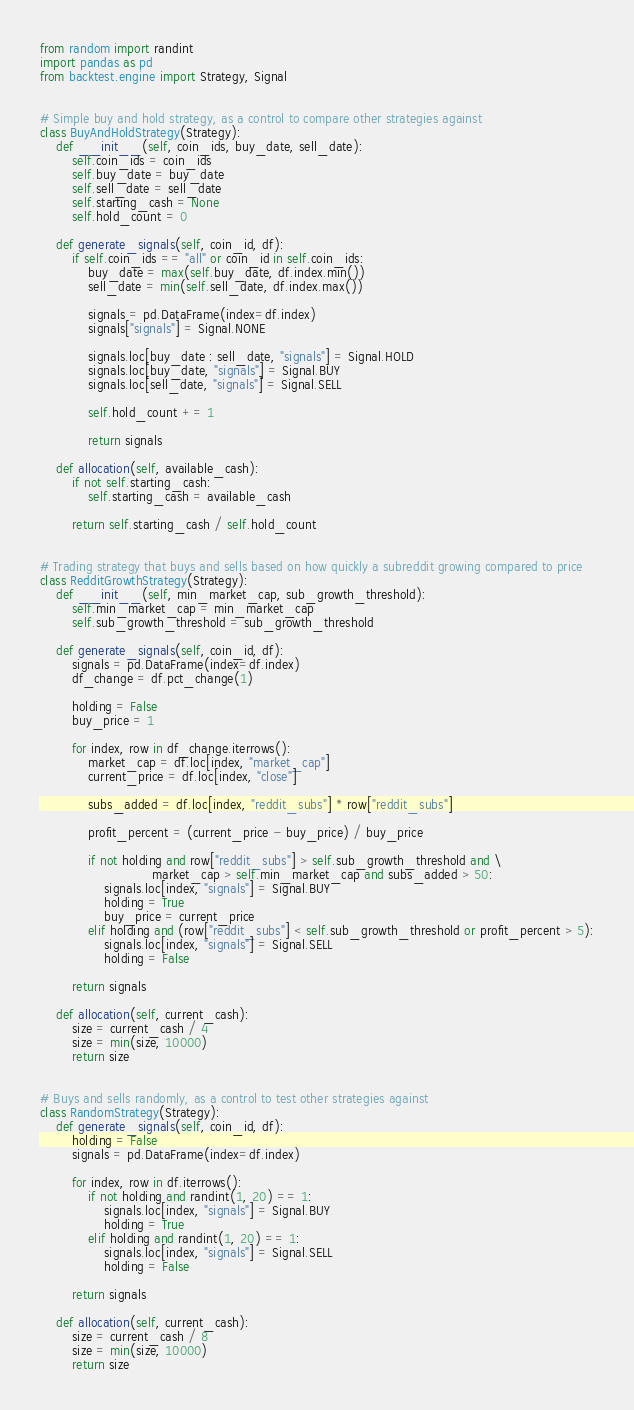Convert code to text. <code><loc_0><loc_0><loc_500><loc_500><_Python_>from random import randint
import pandas as pd
from backtest.engine import Strategy, Signal


# Simple buy and hold strategy, as a control to compare other strategies against
class BuyAndHoldStrategy(Strategy):
    def __init__(self, coin_ids, buy_date, sell_date):
        self.coin_ids = coin_ids
        self.buy_date = buy_date
        self.sell_date = sell_date
        self.starting_cash = None
        self.hold_count = 0

    def generate_signals(self, coin_id, df):
        if self.coin_ids == "all" or coin_id in self.coin_ids:
            buy_date = max(self.buy_date, df.index.min())
            sell_date = min(self.sell_date, df.index.max())

            signals = pd.DataFrame(index=df.index)
            signals["signals"] = Signal.NONE

            signals.loc[buy_date : sell_date, "signals"] = Signal.HOLD
            signals.loc[buy_date, "signals"] = Signal.BUY
            signals.loc[sell_date, "signals"] = Signal.SELL

            self.hold_count += 1

            return signals

    def allocation(self, available_cash):
        if not self.starting_cash:
            self.starting_cash = available_cash

        return self.starting_cash / self.hold_count


# Trading strategy that buys and sells based on how quickly a subreddit growing compared to price
class RedditGrowthStrategy(Strategy):
    def __init__(self, min_market_cap, sub_growth_threshold):
        self.min_market_cap = min_market_cap
        self.sub_growth_threshold = sub_growth_threshold

    def generate_signals(self, coin_id, df):
        signals = pd.DataFrame(index=df.index)
        df_change = df.pct_change(1)

        holding = False
        buy_price = 1

        for index, row in df_change.iterrows():
            market_cap = df.loc[index, "market_cap"]
            current_price = df.loc[index, "close"]

            subs_added = df.loc[index, "reddit_subs"] * row["reddit_subs"]

            profit_percent = (current_price - buy_price) / buy_price

            if not holding and row["reddit_subs"] > self.sub_growth_threshold and \
                            market_cap > self.min_market_cap and subs_added > 50:
                signals.loc[index, "signals"] = Signal.BUY
                holding = True
                buy_price = current_price
            elif holding and (row["reddit_subs"] < self.sub_growth_threshold or profit_percent > 5):
                signals.loc[index, "signals"] = Signal.SELL
                holding = False

        return signals

    def allocation(self, current_cash):
        size = current_cash / 4
        size = min(size, 10000)
        return size


# Buys and sells randomly, as a control to test other strategies against
class RandomStrategy(Strategy):
    def generate_signals(self, coin_id, df):
        holding = False
        signals = pd.DataFrame(index=df.index)

        for index, row in df.iterrows():
            if not holding and randint(1, 20) == 1:
                signals.loc[index, "signals"] = Signal.BUY
                holding = True
            elif holding and randint(1, 20) == 1:
                signals.loc[index, "signals"] = Signal.SELL
                holding = False

        return signals

    def allocation(self, current_cash):
        size = current_cash / 8
        size = min(size, 10000)
        return size
</code> 